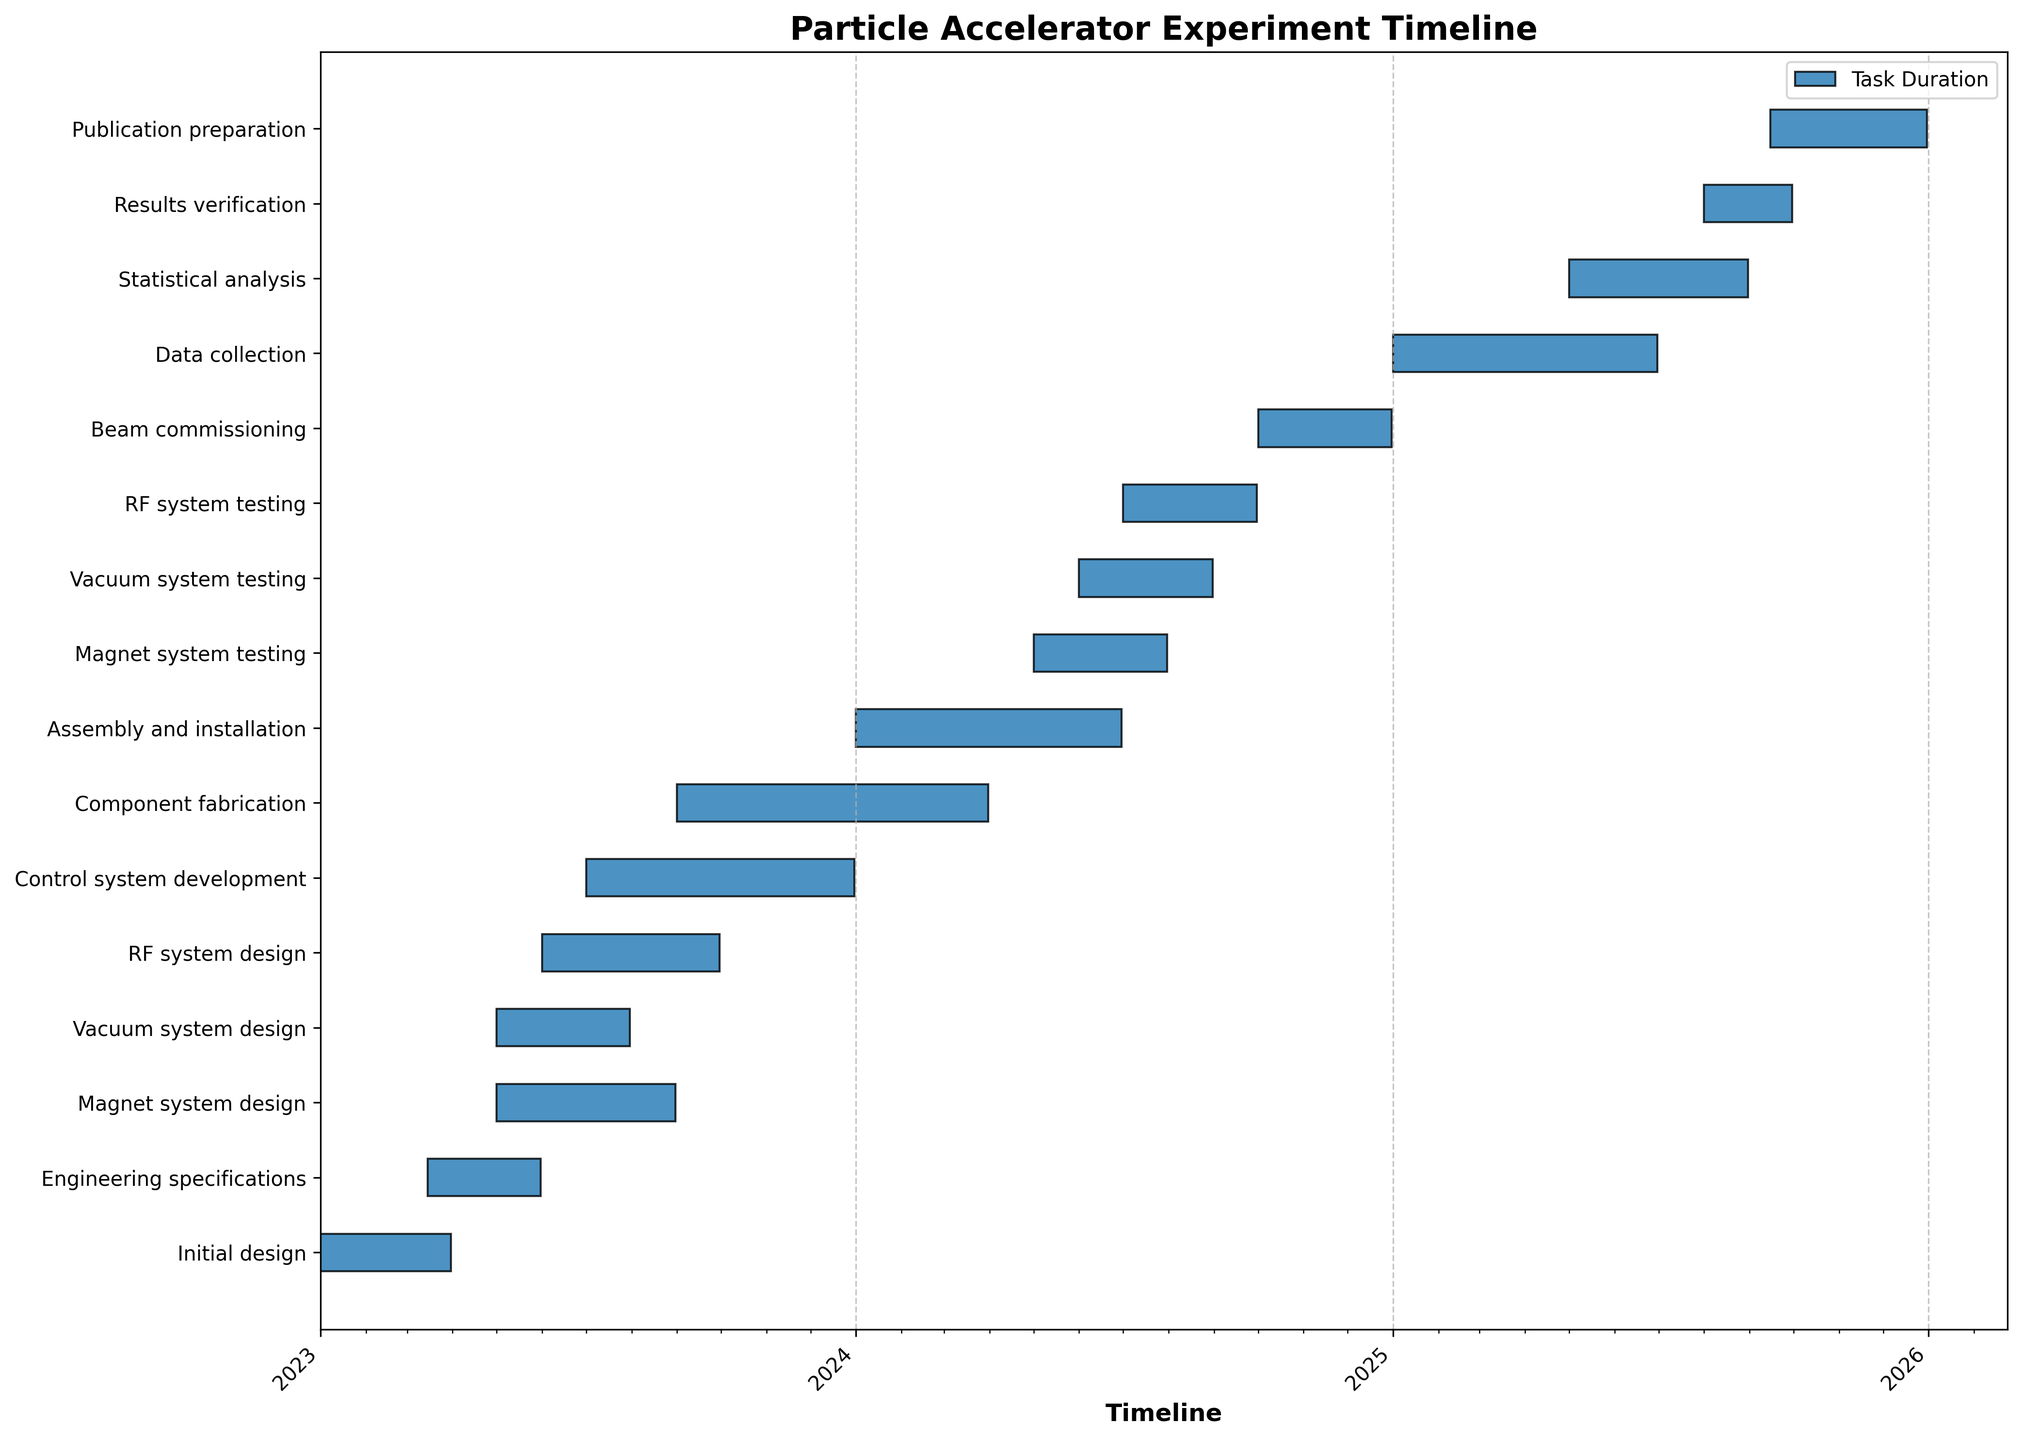Which phase takes the longest time from design to installation? Calculate the duration for each phase from its start date to end date and compare them. Component Fabrication lasts from 2023-09-01 to 2024-03-31, total of 212 days, which is the longest.
Answer: Component fabrication Which tasks are ongoing during August 2023? Check the Gantt bars' span to see which ones include August 2023. Both Magnet System Design, Vacuum System Design, RF System Design, and Control System Development are ongoing.
Answer: Magnet system design, Vacuum system design, RF system design, and Control system development How much overlap is there between Assembly and Installation and Magnet System Testing? Assembly and Installation runs from 2024-01-01 to 2024-06-30, and Magnet System Testing runs from 2024-05-01 to 2024-07-31. The overlap is from 2024-05-01 to 2024-06-30.
Answer: 2 months or 61 days Which task immediately follows "Beam commissioning"? Look at the Gantt chart to identify the task starting right after Beam Commissioning ends on 2024-12-31. Data Collection starts on 2025-01-01, immediately following Beam Commissioning.
Answer: Data collection During what month in 2024 does RF System Testing begin? Identify the start date for RF System Testing on the Gantt chart. It begins in July 2024.
Answer: July How many tasks run simultaneously with "Initial Design"? Initial Design runs from 2023-01-01 to 2023-03-31. Check how many other tasks overlap with these dates. Engineering Specifications starts on 2023-03-15 and overlaps with Initial Design for 17 days.
Answer: 1 What is the duration of the Beam Commissioning phase? Check the start and end dates of Beam Commissioning on the Gantt chart, which runs from 2024-10-01 to 2024-12-31. The duration is 3 months.
Answer: 3 months Is there any task in 2024 that starts and ends within the same year? Identify tasks in 2024 and check their start and end dates. Magnet System Testing, Vacuum System Testing, RF System Testing, and Beam Commissioning all start and end within 2024.
Answer: Yes Which tasks have overlapping periods with "Control System Development"? Check the periods of tasks from the Gantt chart that overlap with Control System Development (2023-07-01 to 2023-12-31). RF System Design overlaps from 2023-07-01 to 2023-09-30, and Component Fabrication starts on 2023-09-01.
Answer: RF system design and Component fabrication 